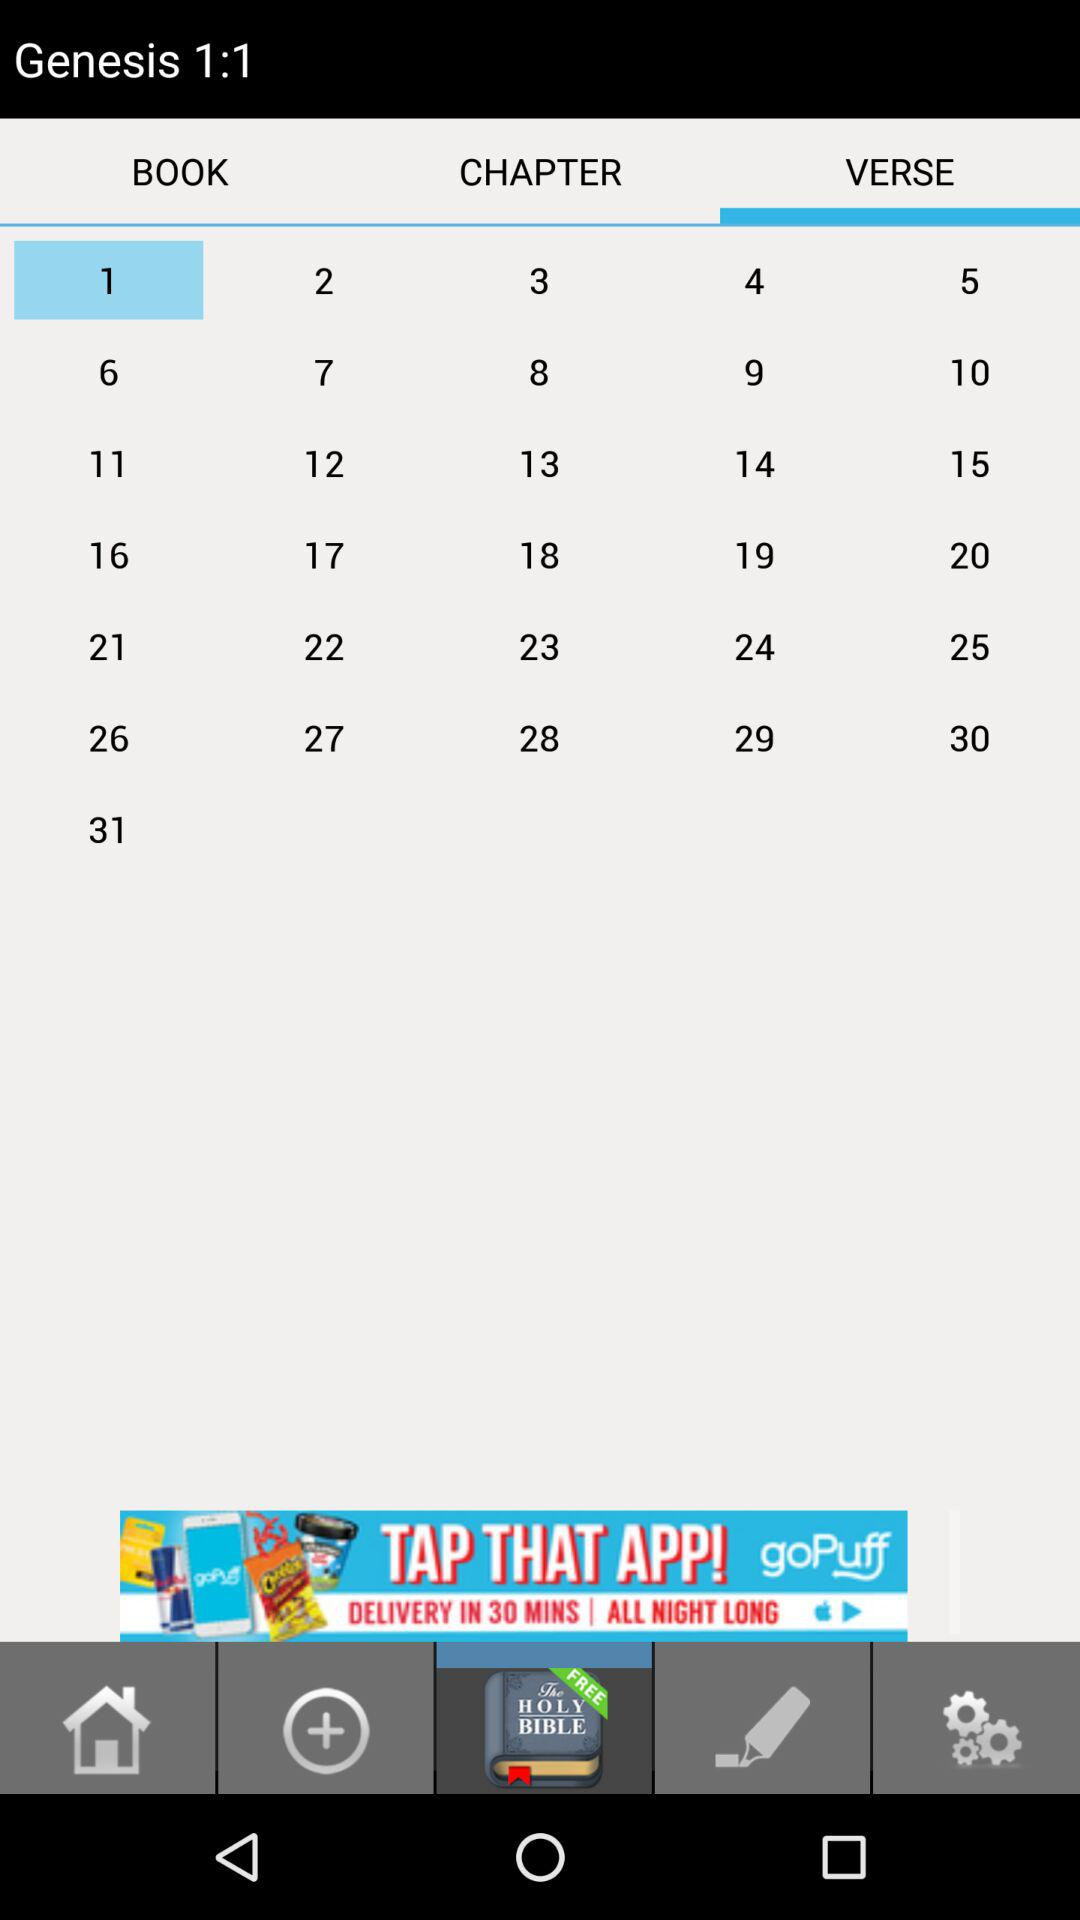How many text blocks are on the screen?
Answer the question using a single word or phrase. 31 